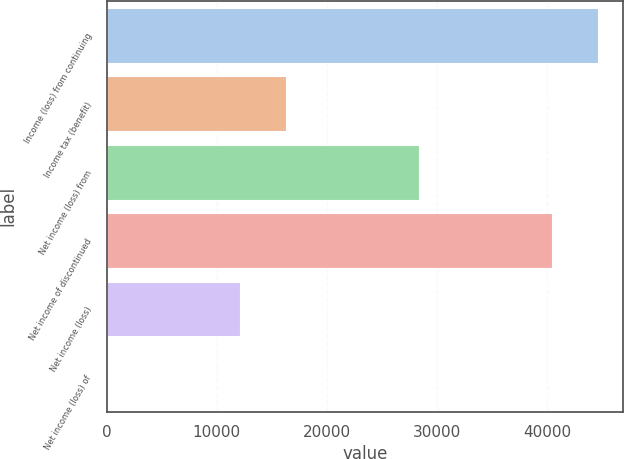Convert chart. <chart><loc_0><loc_0><loc_500><loc_500><bar_chart><fcel>Income (loss) from continuing<fcel>Income tax (benefit)<fcel>Net income (loss) from<fcel>Net income of discontinued<fcel>Net income (loss)<fcel>Net income (loss) of<nl><fcel>44667.4<fcel>16319.4<fcel>28348<fcel>40461<fcel>12113<fcel>0.09<nl></chart> 